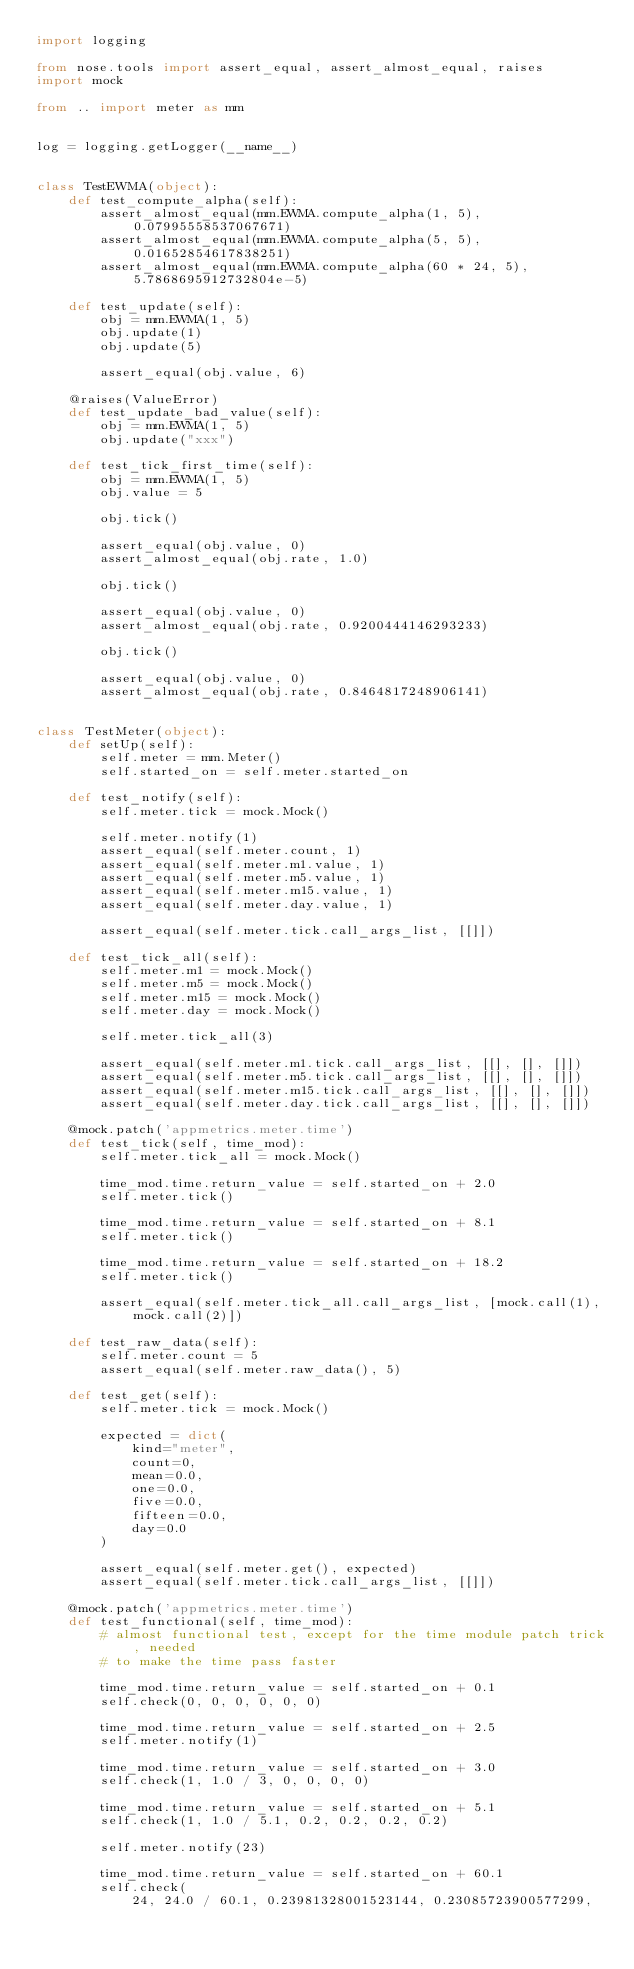Convert code to text. <code><loc_0><loc_0><loc_500><loc_500><_Python_>import logging

from nose.tools import assert_equal, assert_almost_equal, raises
import mock

from .. import meter as mm


log = logging.getLogger(__name__)


class TestEWMA(object):
    def test_compute_alpha(self):
        assert_almost_equal(mm.EWMA.compute_alpha(1, 5), 0.07995558537067671)
        assert_almost_equal(mm.EWMA.compute_alpha(5, 5), 0.01652854617838251)
        assert_almost_equal(mm.EWMA.compute_alpha(60 * 24, 5), 5.7868695912732804e-5)

    def test_update(self):
        obj = mm.EWMA(1, 5)
        obj.update(1)
        obj.update(5)

        assert_equal(obj.value, 6)

    @raises(ValueError)
    def test_update_bad_value(self):
        obj = mm.EWMA(1, 5)
        obj.update("xxx")

    def test_tick_first_time(self):
        obj = mm.EWMA(1, 5)
        obj.value = 5

        obj.tick()

        assert_equal(obj.value, 0)
        assert_almost_equal(obj.rate, 1.0)

        obj.tick()

        assert_equal(obj.value, 0)
        assert_almost_equal(obj.rate, 0.9200444146293233)

        obj.tick()

        assert_equal(obj.value, 0)
        assert_almost_equal(obj.rate, 0.8464817248906141)


class TestMeter(object):
    def setUp(self):
        self.meter = mm.Meter()
        self.started_on = self.meter.started_on

    def test_notify(self):
        self.meter.tick = mock.Mock()

        self.meter.notify(1)
        assert_equal(self.meter.count, 1)
        assert_equal(self.meter.m1.value, 1)
        assert_equal(self.meter.m5.value, 1)
        assert_equal(self.meter.m15.value, 1)
        assert_equal(self.meter.day.value, 1)

        assert_equal(self.meter.tick.call_args_list, [[]])

    def test_tick_all(self):
        self.meter.m1 = mock.Mock()
        self.meter.m5 = mock.Mock()
        self.meter.m15 = mock.Mock()
        self.meter.day = mock.Mock()

        self.meter.tick_all(3)

        assert_equal(self.meter.m1.tick.call_args_list, [[], [], []])
        assert_equal(self.meter.m5.tick.call_args_list, [[], [], []])
        assert_equal(self.meter.m15.tick.call_args_list, [[], [], []])
        assert_equal(self.meter.day.tick.call_args_list, [[], [], []])

    @mock.patch('appmetrics.meter.time')
    def test_tick(self, time_mod):
        self.meter.tick_all = mock.Mock()

        time_mod.time.return_value = self.started_on + 2.0
        self.meter.tick()

        time_mod.time.return_value = self.started_on + 8.1
        self.meter.tick()

        time_mod.time.return_value = self.started_on + 18.2
        self.meter.tick()

        assert_equal(self.meter.tick_all.call_args_list, [mock.call(1), mock.call(2)])

    def test_raw_data(self):
        self.meter.count = 5
        assert_equal(self.meter.raw_data(), 5)

    def test_get(self):
        self.meter.tick = mock.Mock()

        expected = dict(
            kind="meter",
            count=0,
            mean=0.0,
            one=0.0,
            five=0.0,
            fifteen=0.0,
            day=0.0
        )

        assert_equal(self.meter.get(), expected)
        assert_equal(self.meter.tick.call_args_list, [[]])

    @mock.patch('appmetrics.meter.time')
    def test_functional(self, time_mod):
        # almost functional test, except for the time module patch trick, needed
        # to make the time pass faster

        time_mod.time.return_value = self.started_on + 0.1
        self.check(0, 0, 0, 0, 0, 0)

        time_mod.time.return_value = self.started_on + 2.5
        self.meter.notify(1)

        time_mod.time.return_value = self.started_on + 3.0
        self.check(1, 1.0 / 3, 0, 0, 0, 0)

        time_mod.time.return_value = self.started_on + 5.1
        self.check(1, 1.0 / 5.1, 0.2, 0.2, 0.2, 0.2)

        self.meter.notify(23)

        time_mod.time.return_value = self.started_on + 60.1
        self.check(
            24, 24.0 / 60.1, 0.23981328001523144, 0.23085723900577299,</code> 